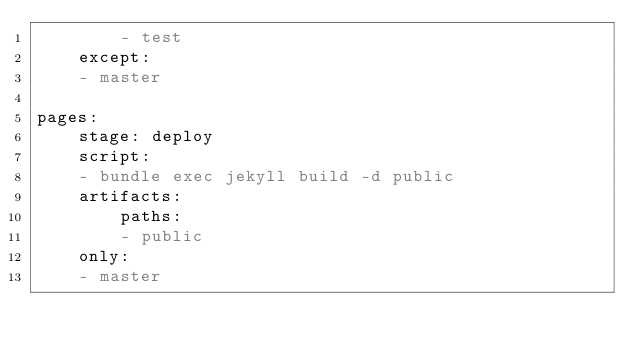<code> <loc_0><loc_0><loc_500><loc_500><_YAML_>        - test
    except:
    - master

pages:
    stage: deploy
    script:
    - bundle exec jekyll build -d public
    artifacts:
        paths:
        - public
    only:
    - master
</code> 